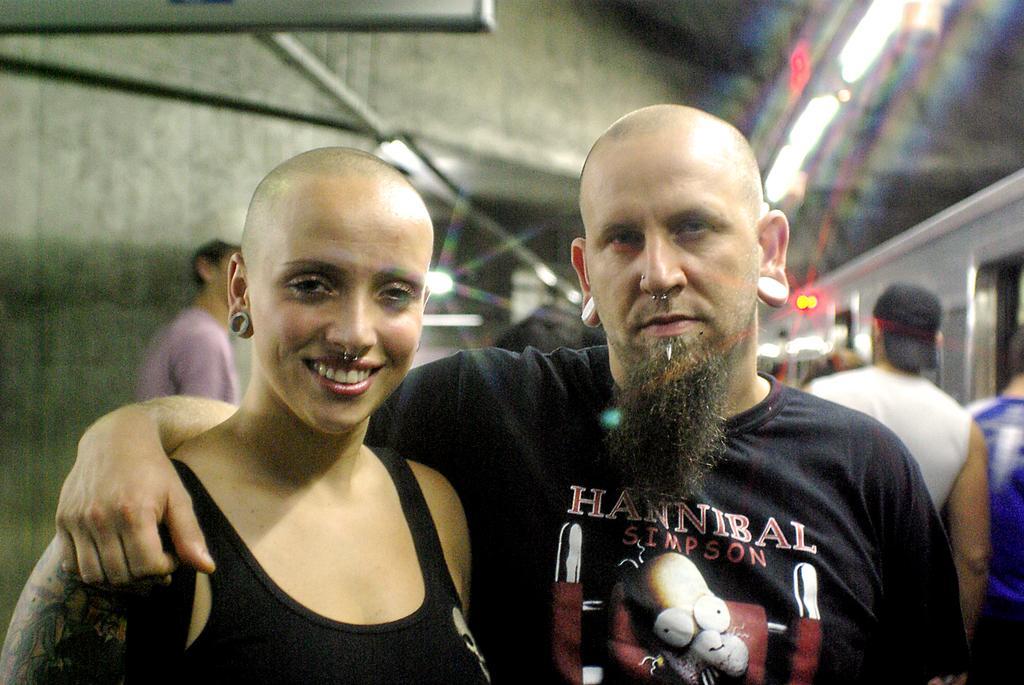How would you summarize this image in a sentence or two? This 2 persons are highlighted in this picture. This woman smiles beautifully. This man wore black t-shirt. He kept his hand on this woman. Backside few persons are standing. The person in white t-shirt wore cap. Far there are lights attached with roof top. 